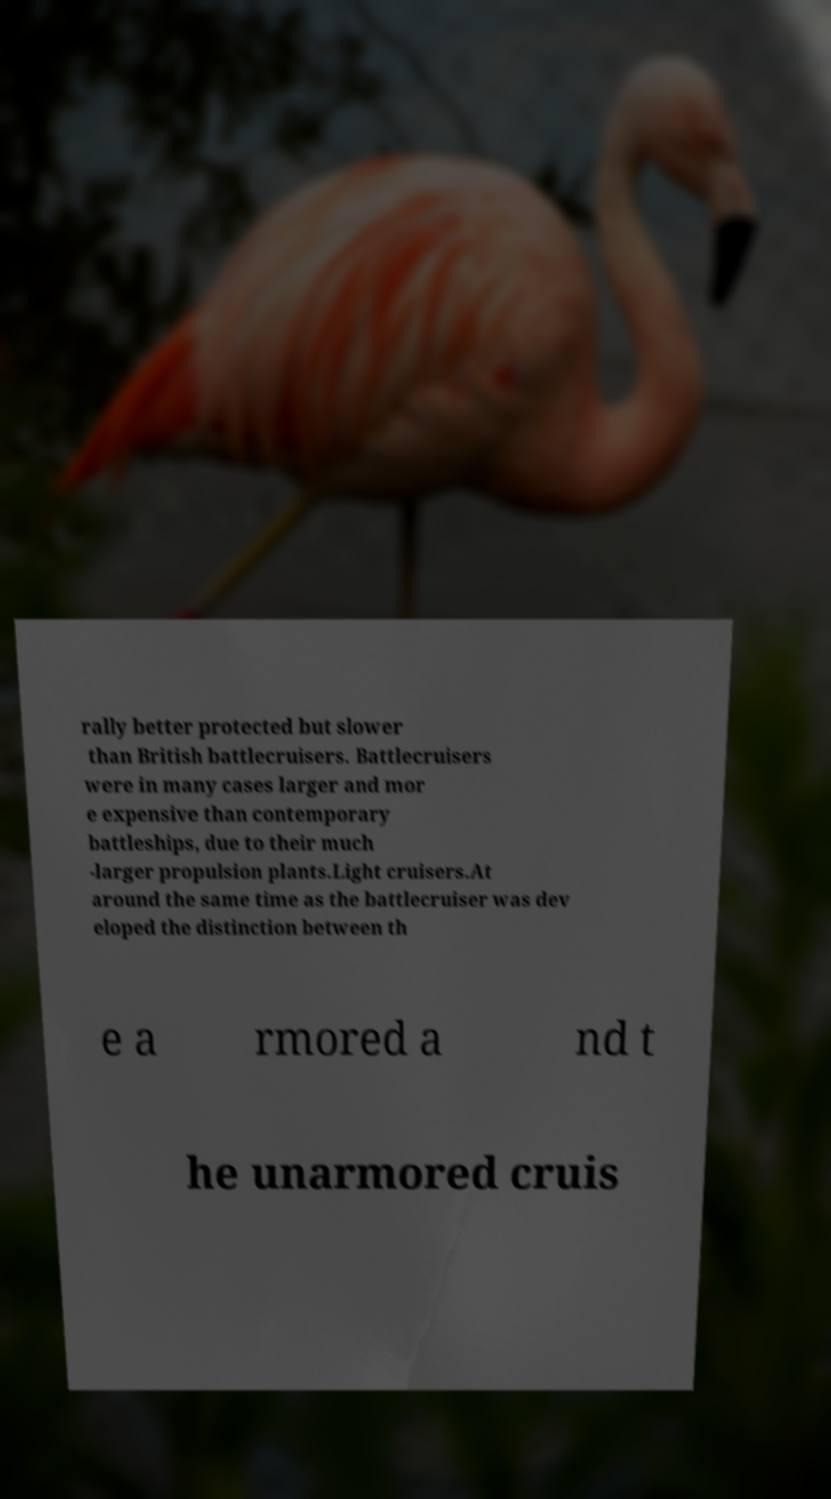Can you accurately transcribe the text from the provided image for me? rally better protected but slower than British battlecruisers. Battlecruisers were in many cases larger and mor e expensive than contemporary battleships, due to their much -larger propulsion plants.Light cruisers.At around the same time as the battlecruiser was dev eloped the distinction between th e a rmored a nd t he unarmored cruis 